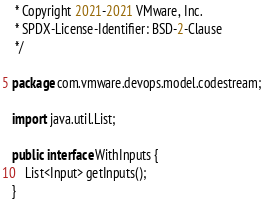<code> <loc_0><loc_0><loc_500><loc_500><_Java_> * Copyright 2021-2021 VMware, Inc.
 * SPDX-License-Identifier: BSD-2-Clause
 */

package com.vmware.devops.model.codestream;

import java.util.List;

public interface WithInputs {
    List<Input> getInputs();
}
</code> 